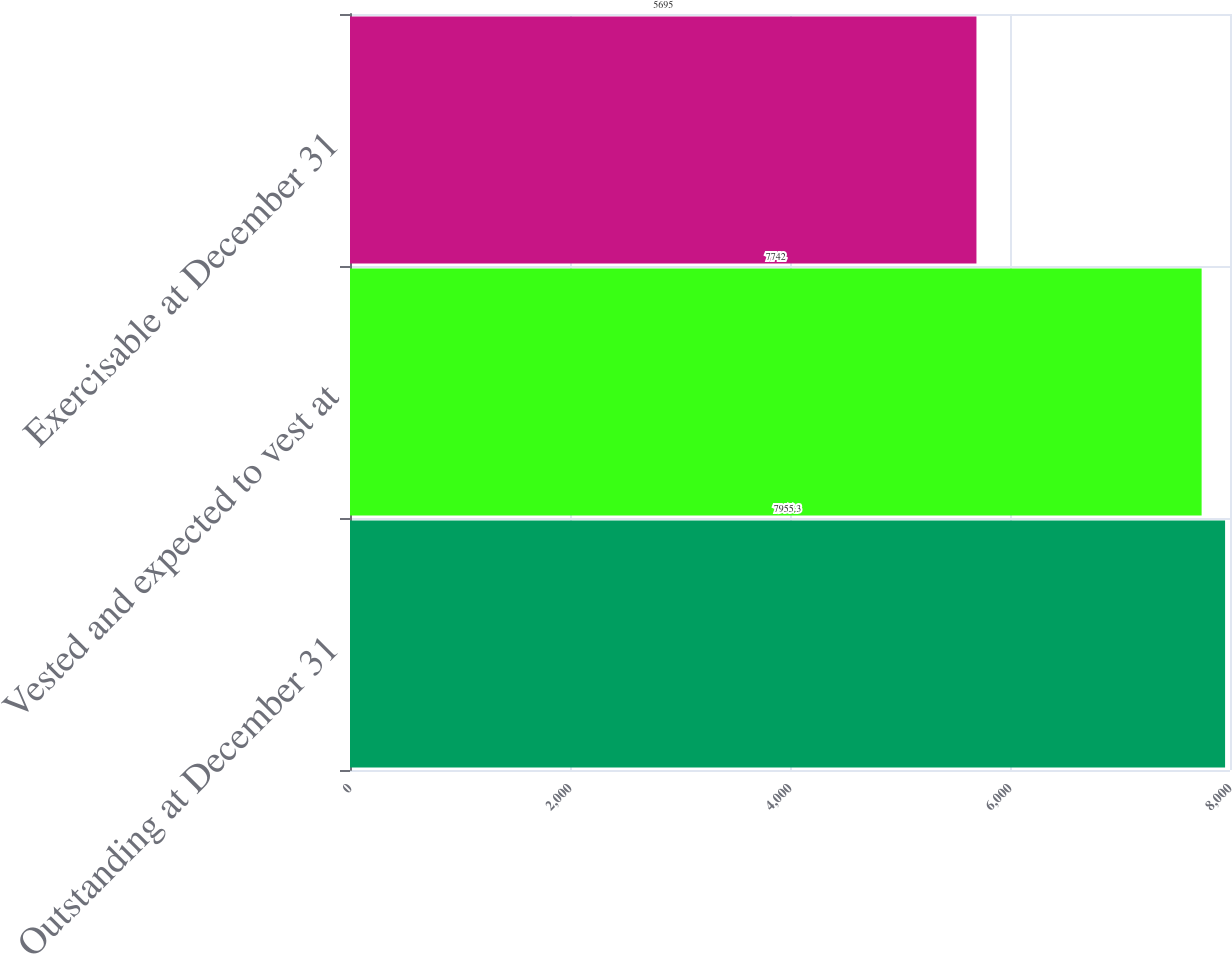Convert chart to OTSL. <chart><loc_0><loc_0><loc_500><loc_500><bar_chart><fcel>Outstanding at December 31<fcel>Vested and expected to vest at<fcel>Exercisable at December 31<nl><fcel>7955.3<fcel>7742<fcel>5695<nl></chart> 